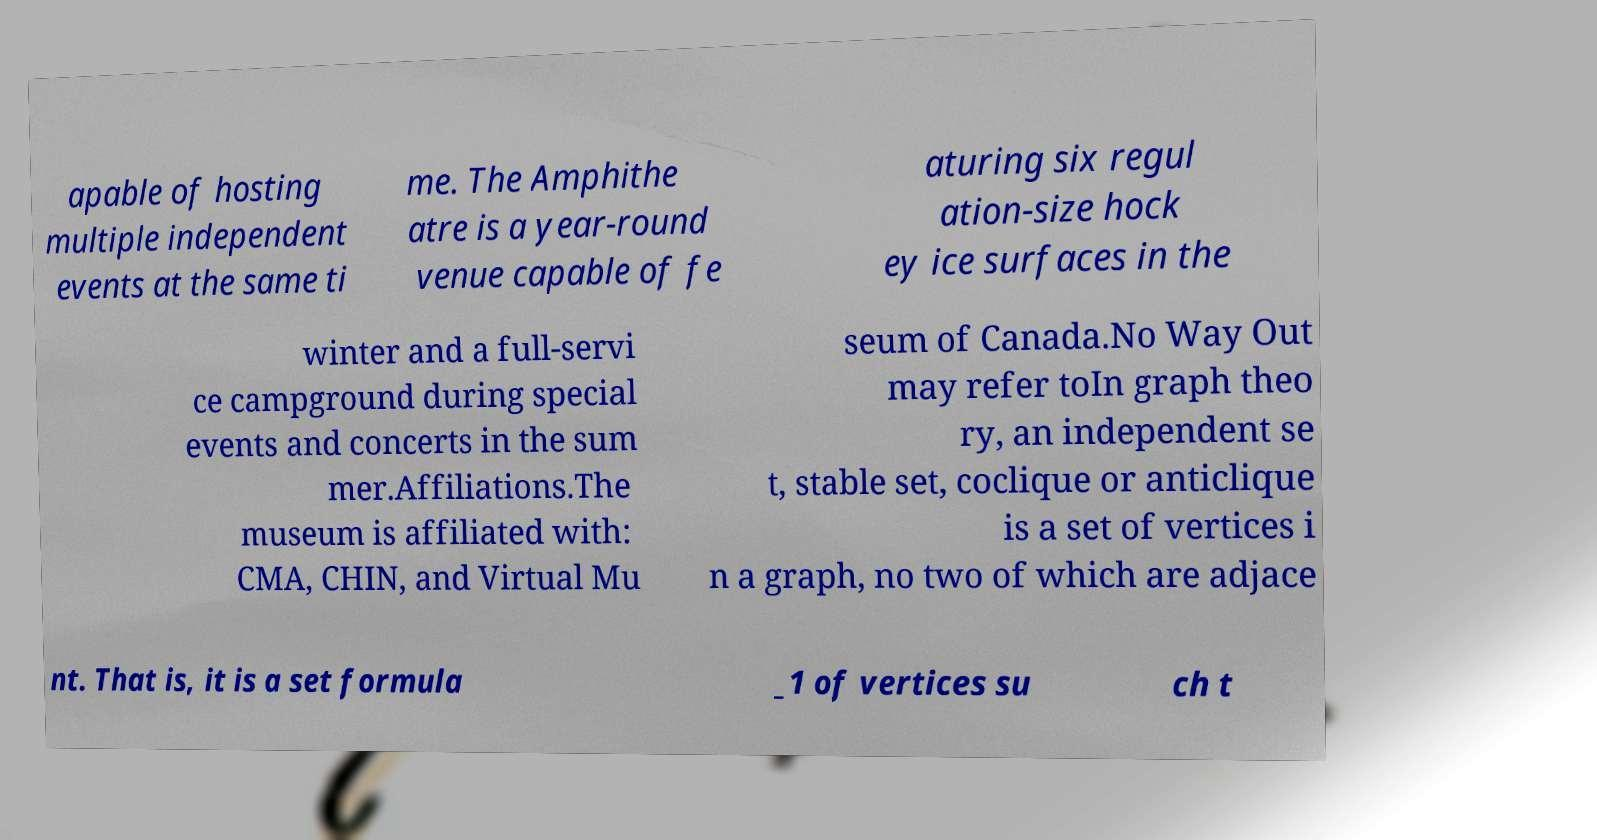For documentation purposes, I need the text within this image transcribed. Could you provide that? apable of hosting multiple independent events at the same ti me. The Amphithe atre is a year-round venue capable of fe aturing six regul ation-size hock ey ice surfaces in the winter and a full-servi ce campground during special events and concerts in the sum mer.Affiliations.The museum is affiliated with: CMA, CHIN, and Virtual Mu seum of Canada.No Way Out may refer toIn graph theo ry, an independent se t, stable set, coclique or anticlique is a set of vertices i n a graph, no two of which are adjace nt. That is, it is a set formula _1 of vertices su ch t 